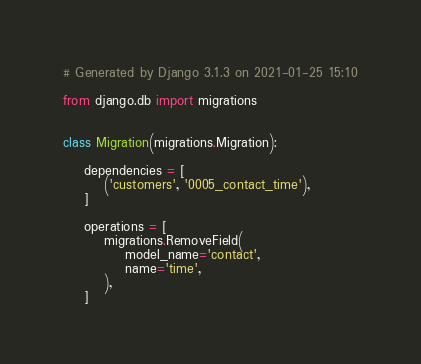Convert code to text. <code><loc_0><loc_0><loc_500><loc_500><_Python_># Generated by Django 3.1.3 on 2021-01-25 15:10

from django.db import migrations


class Migration(migrations.Migration):

    dependencies = [
        ('customers', '0005_contact_time'),
    ]

    operations = [
        migrations.RemoveField(
            model_name='contact',
            name='time',
        ),
    ]
</code> 